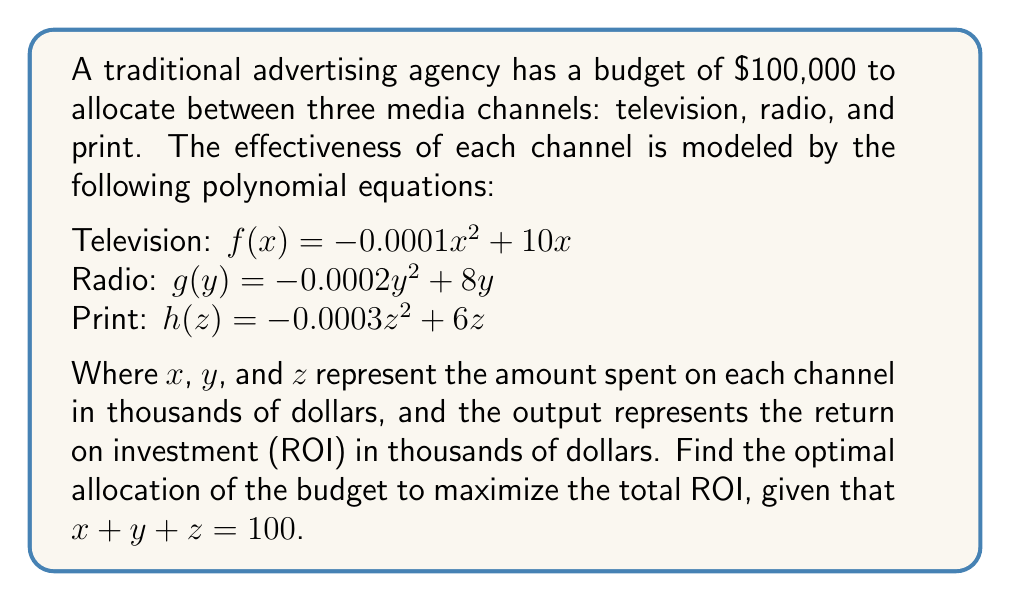Give your solution to this math problem. To solve this problem, we'll use the method of Lagrange multipliers:

1) First, we define the function to maximize:
   $L(x, y, z, \lambda) = f(x) + g(y) + h(z) + \lambda(100 - x - y - z)$

2) Now, we take partial derivatives and set them equal to zero:

   $\frac{\partial L}{\partial x} = -0.0002x + 10 - \lambda = 0$
   $\frac{\partial L}{\partial y} = -0.0004y + 8 - \lambda = 0$
   $\frac{\partial L}{\partial z} = -0.0006z + 6 - \lambda = 0$
   $\frac{\partial L}{\partial \lambda} = 100 - x - y - z = 0$

3) From these equations, we can derive:

   $x = 50000 - 5000\lambda$
   $y = 20000 - 2500\lambda$
   $z = 10000 - 1667\lambda$

4) Substituting these into the constraint equation:

   $100 = (50000 - 5000\lambda) + (20000 - 2500\lambda) + (10000 - 1667\lambda)$
   $100000 = 80000 - 9167\lambda$
   $9167\lambda = -20000$
   $\lambda = -2.18$

5) Now we can solve for $x$, $y$, and $z$:

   $x = 50000 - 5000(-2.18) = 60900$
   $y = 20000 - 2500(-2.18) = 25450$
   $z = 10000 - 1667(-2.18) = 13650$

6) Rounding to the nearest thousand dollars:

   $x = 61$, $y = 25$, $z = 14$

7) We can verify that this sums to 100 and calculate the total ROI:

   ROI = $f(61) + g(25) + h(14)$
       = $(-0.0001(61)^2 + 10(61)) + (-0.0002(25)^2 + 8(25)) + (-0.0003(14)^2 + 6(14))$
       = $572.79 + 187.5 + 80.94$
       = $841.23$ thousand dollars
Answer: Television: $61,000, Radio: $25,000, Print: $14,000. Total ROI: $841,230. 